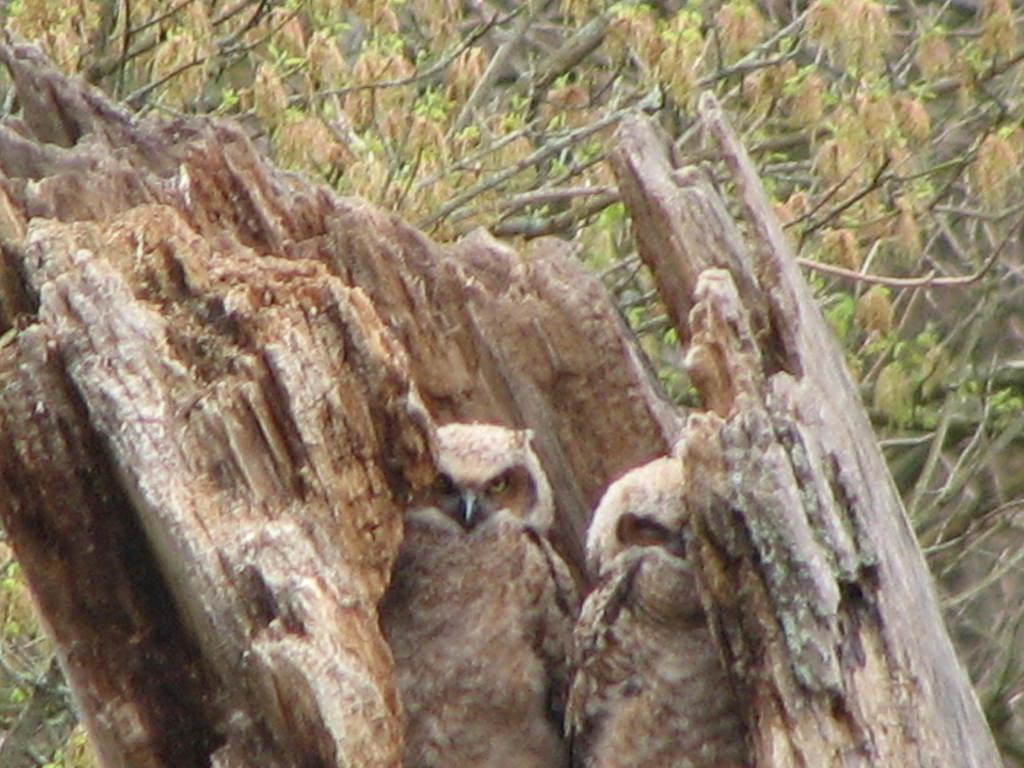What type of animals can be seen inside the tree trunk in the image? There are owls inside the tree trunk in the image. What can be seen on the tree in the image besides the owls? There are branches with leaves visible in the image. What type of shirt is the owl wearing in the image? There are no owls wearing shirts in the image; they are not dressed in human clothing. 